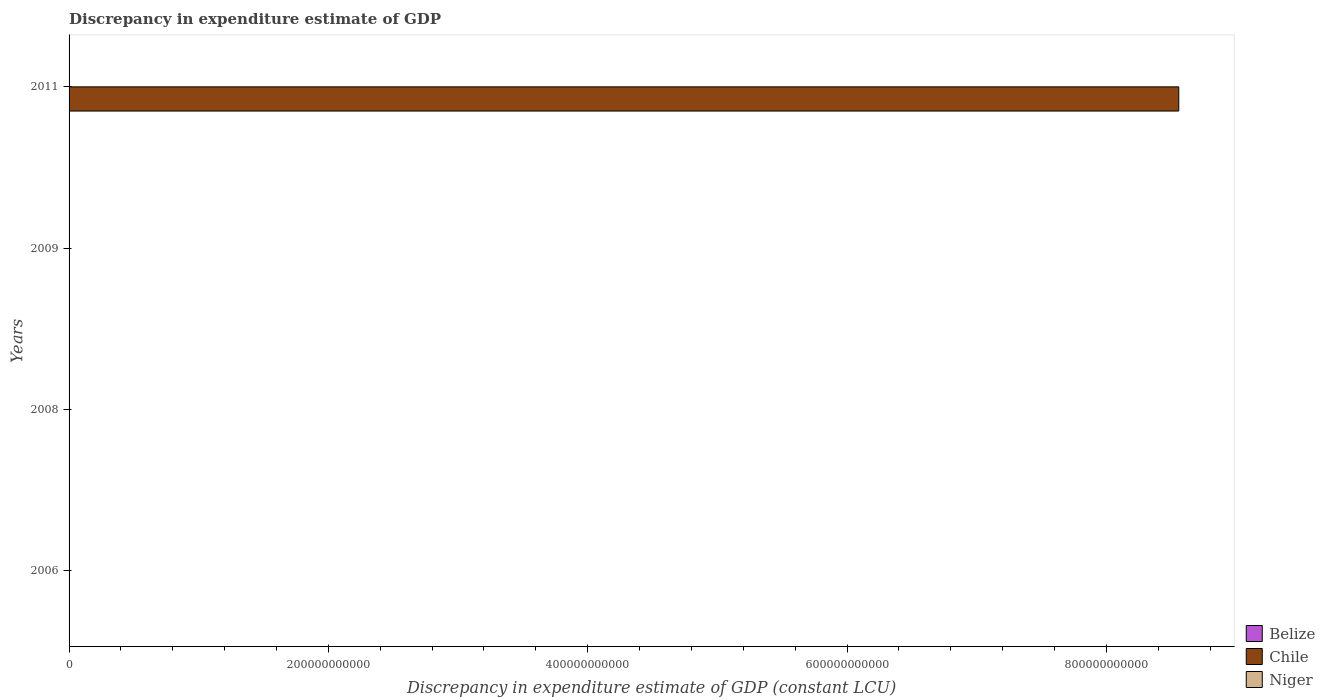How many different coloured bars are there?
Provide a short and direct response. 2. Are the number of bars on each tick of the Y-axis equal?
Provide a succinct answer. No. What is the label of the 2nd group of bars from the top?
Give a very brief answer. 2009. In how many cases, is the number of bars for a given year not equal to the number of legend labels?
Provide a short and direct response. 4. Across all years, what is the maximum discrepancy in expenditure estimate of GDP in Chile?
Provide a short and direct response. 8.56e+11. Across all years, what is the minimum discrepancy in expenditure estimate of GDP in Niger?
Your answer should be compact. 0. In which year was the discrepancy in expenditure estimate of GDP in Chile maximum?
Your answer should be very brief. 2011. What is the total discrepancy in expenditure estimate of GDP in Niger in the graph?
Give a very brief answer. 2.28e+06. What is the difference between the discrepancy in expenditure estimate of GDP in Niger in 2009 and that in 2011?
Offer a terse response. 7.21e+05. What is the difference between the discrepancy in expenditure estimate of GDP in Belize in 2006 and the discrepancy in expenditure estimate of GDP in Niger in 2011?
Give a very brief answer. -2.79e+05. In how many years, is the discrepancy in expenditure estimate of GDP in Belize greater than 840000000000 LCU?
Give a very brief answer. 0. What is the ratio of the discrepancy in expenditure estimate of GDP in Niger in 2008 to that in 2011?
Offer a terse response. 3.58. What is the difference between the highest and the lowest discrepancy in expenditure estimate of GDP in Chile?
Offer a very short reply. 8.56e+11. In how many years, is the discrepancy in expenditure estimate of GDP in Niger greater than the average discrepancy in expenditure estimate of GDP in Niger taken over all years?
Provide a succinct answer. 2. Is the sum of the discrepancy in expenditure estimate of GDP in Niger in 2009 and 2011 greater than the maximum discrepancy in expenditure estimate of GDP in Chile across all years?
Provide a succinct answer. No. Are all the bars in the graph horizontal?
Your answer should be compact. Yes. What is the difference between two consecutive major ticks on the X-axis?
Your answer should be very brief. 2.00e+11. Does the graph contain grids?
Your answer should be very brief. No. Where does the legend appear in the graph?
Provide a short and direct response. Bottom right. How many legend labels are there?
Make the answer very short. 3. How are the legend labels stacked?
Offer a terse response. Vertical. What is the title of the graph?
Keep it short and to the point. Discrepancy in expenditure estimate of GDP. What is the label or title of the X-axis?
Provide a succinct answer. Discrepancy in expenditure estimate of GDP (constant LCU). What is the label or title of the Y-axis?
Keep it short and to the point. Years. What is the Discrepancy in expenditure estimate of GDP (constant LCU) of Chile in 2006?
Provide a short and direct response. 0. What is the Discrepancy in expenditure estimate of GDP (constant LCU) of Niger in 2006?
Your answer should be compact. 0. What is the Discrepancy in expenditure estimate of GDP (constant LCU) of Niger in 2008?
Ensure brevity in your answer.  1.00e+06. What is the Discrepancy in expenditure estimate of GDP (constant LCU) of Belize in 2009?
Your answer should be compact. 0. What is the Discrepancy in expenditure estimate of GDP (constant LCU) of Chile in 2009?
Offer a very short reply. 1.88. What is the Discrepancy in expenditure estimate of GDP (constant LCU) in Belize in 2011?
Provide a short and direct response. 0. What is the Discrepancy in expenditure estimate of GDP (constant LCU) of Chile in 2011?
Provide a succinct answer. 8.56e+11. What is the Discrepancy in expenditure estimate of GDP (constant LCU) of Niger in 2011?
Provide a succinct answer. 2.79e+05. Across all years, what is the maximum Discrepancy in expenditure estimate of GDP (constant LCU) of Chile?
Your answer should be very brief. 8.56e+11. Across all years, what is the maximum Discrepancy in expenditure estimate of GDP (constant LCU) in Niger?
Make the answer very short. 1.00e+06. What is the total Discrepancy in expenditure estimate of GDP (constant LCU) of Belize in the graph?
Offer a terse response. 0. What is the total Discrepancy in expenditure estimate of GDP (constant LCU) in Chile in the graph?
Ensure brevity in your answer.  8.56e+11. What is the total Discrepancy in expenditure estimate of GDP (constant LCU) in Niger in the graph?
Ensure brevity in your answer.  2.28e+06. What is the difference between the Discrepancy in expenditure estimate of GDP (constant LCU) of Niger in 2008 and that in 2011?
Offer a terse response. 7.21e+05. What is the difference between the Discrepancy in expenditure estimate of GDP (constant LCU) of Chile in 2009 and that in 2011?
Your response must be concise. -8.56e+11. What is the difference between the Discrepancy in expenditure estimate of GDP (constant LCU) of Niger in 2009 and that in 2011?
Keep it short and to the point. 7.21e+05. What is the difference between the Discrepancy in expenditure estimate of GDP (constant LCU) of Chile in 2009 and the Discrepancy in expenditure estimate of GDP (constant LCU) of Niger in 2011?
Keep it short and to the point. -2.79e+05. What is the average Discrepancy in expenditure estimate of GDP (constant LCU) in Chile per year?
Your response must be concise. 2.14e+11. What is the average Discrepancy in expenditure estimate of GDP (constant LCU) in Niger per year?
Offer a terse response. 5.70e+05. In the year 2009, what is the difference between the Discrepancy in expenditure estimate of GDP (constant LCU) in Chile and Discrepancy in expenditure estimate of GDP (constant LCU) in Niger?
Provide a short and direct response. -1.00e+06. In the year 2011, what is the difference between the Discrepancy in expenditure estimate of GDP (constant LCU) in Chile and Discrepancy in expenditure estimate of GDP (constant LCU) in Niger?
Keep it short and to the point. 8.56e+11. What is the ratio of the Discrepancy in expenditure estimate of GDP (constant LCU) of Niger in 2008 to that in 2011?
Your answer should be compact. 3.58. What is the ratio of the Discrepancy in expenditure estimate of GDP (constant LCU) in Chile in 2009 to that in 2011?
Keep it short and to the point. 0. What is the ratio of the Discrepancy in expenditure estimate of GDP (constant LCU) of Niger in 2009 to that in 2011?
Make the answer very short. 3.58. What is the difference between the highest and the second highest Discrepancy in expenditure estimate of GDP (constant LCU) of Niger?
Keep it short and to the point. 0. What is the difference between the highest and the lowest Discrepancy in expenditure estimate of GDP (constant LCU) in Chile?
Give a very brief answer. 8.56e+11. What is the difference between the highest and the lowest Discrepancy in expenditure estimate of GDP (constant LCU) in Niger?
Your answer should be compact. 1.00e+06. 